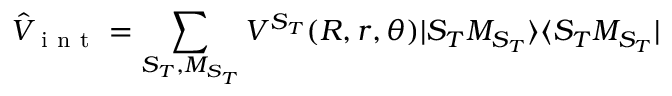<formula> <loc_0><loc_0><loc_500><loc_500>{ } \hat { V } _ { i n t } = \sum _ { S _ { T } , M _ { S _ { T } } } V ^ { S _ { T } } ( R , r , \theta ) | S _ { T } M _ { S _ { T } } \rangle \langle S _ { T } M _ { S _ { T } } |</formula> 